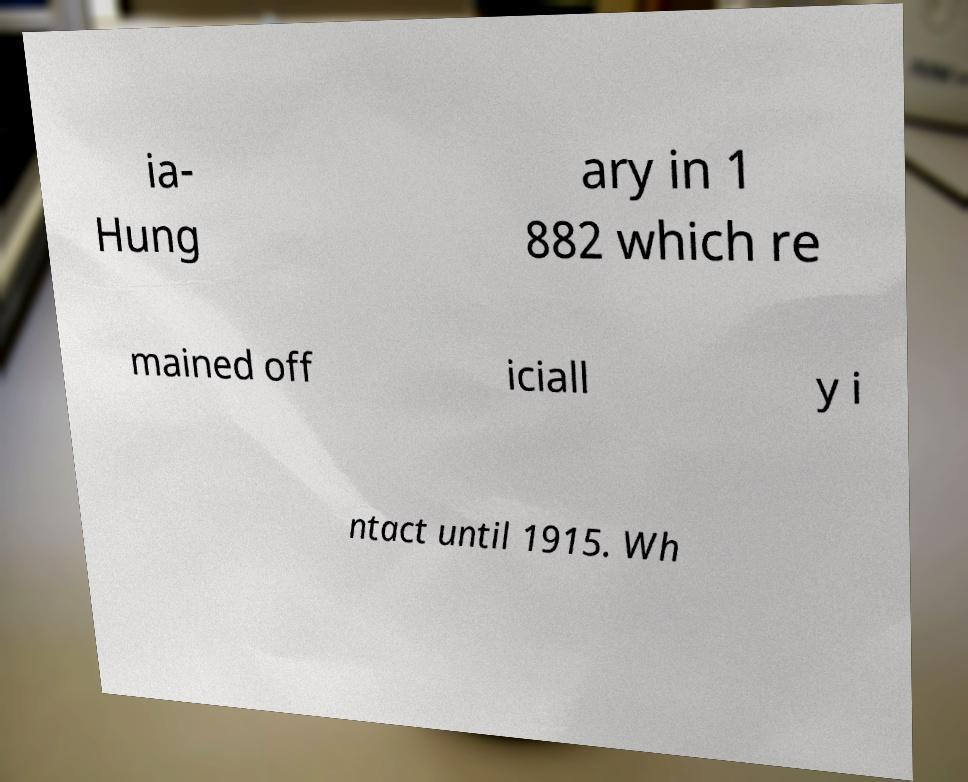I need the written content from this picture converted into text. Can you do that? ia- Hung ary in 1 882 which re mained off iciall y i ntact until 1915. Wh 